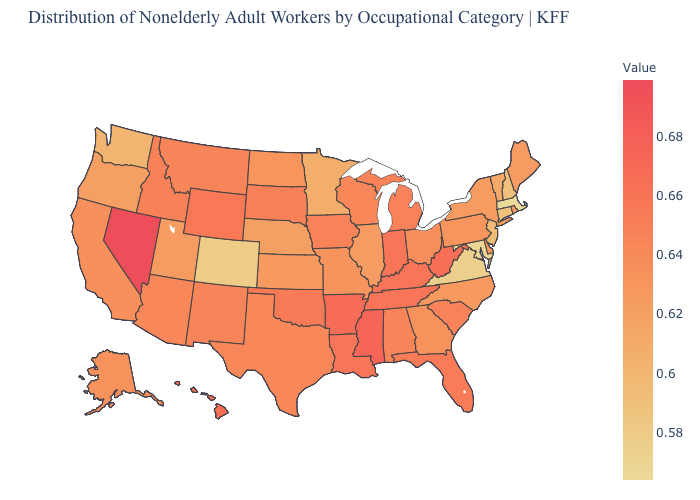Which states have the lowest value in the Northeast?
Keep it brief. Massachusetts. Which states have the lowest value in the USA?
Concise answer only. Massachusetts. Which states have the lowest value in the USA?
Keep it brief. Massachusetts. 